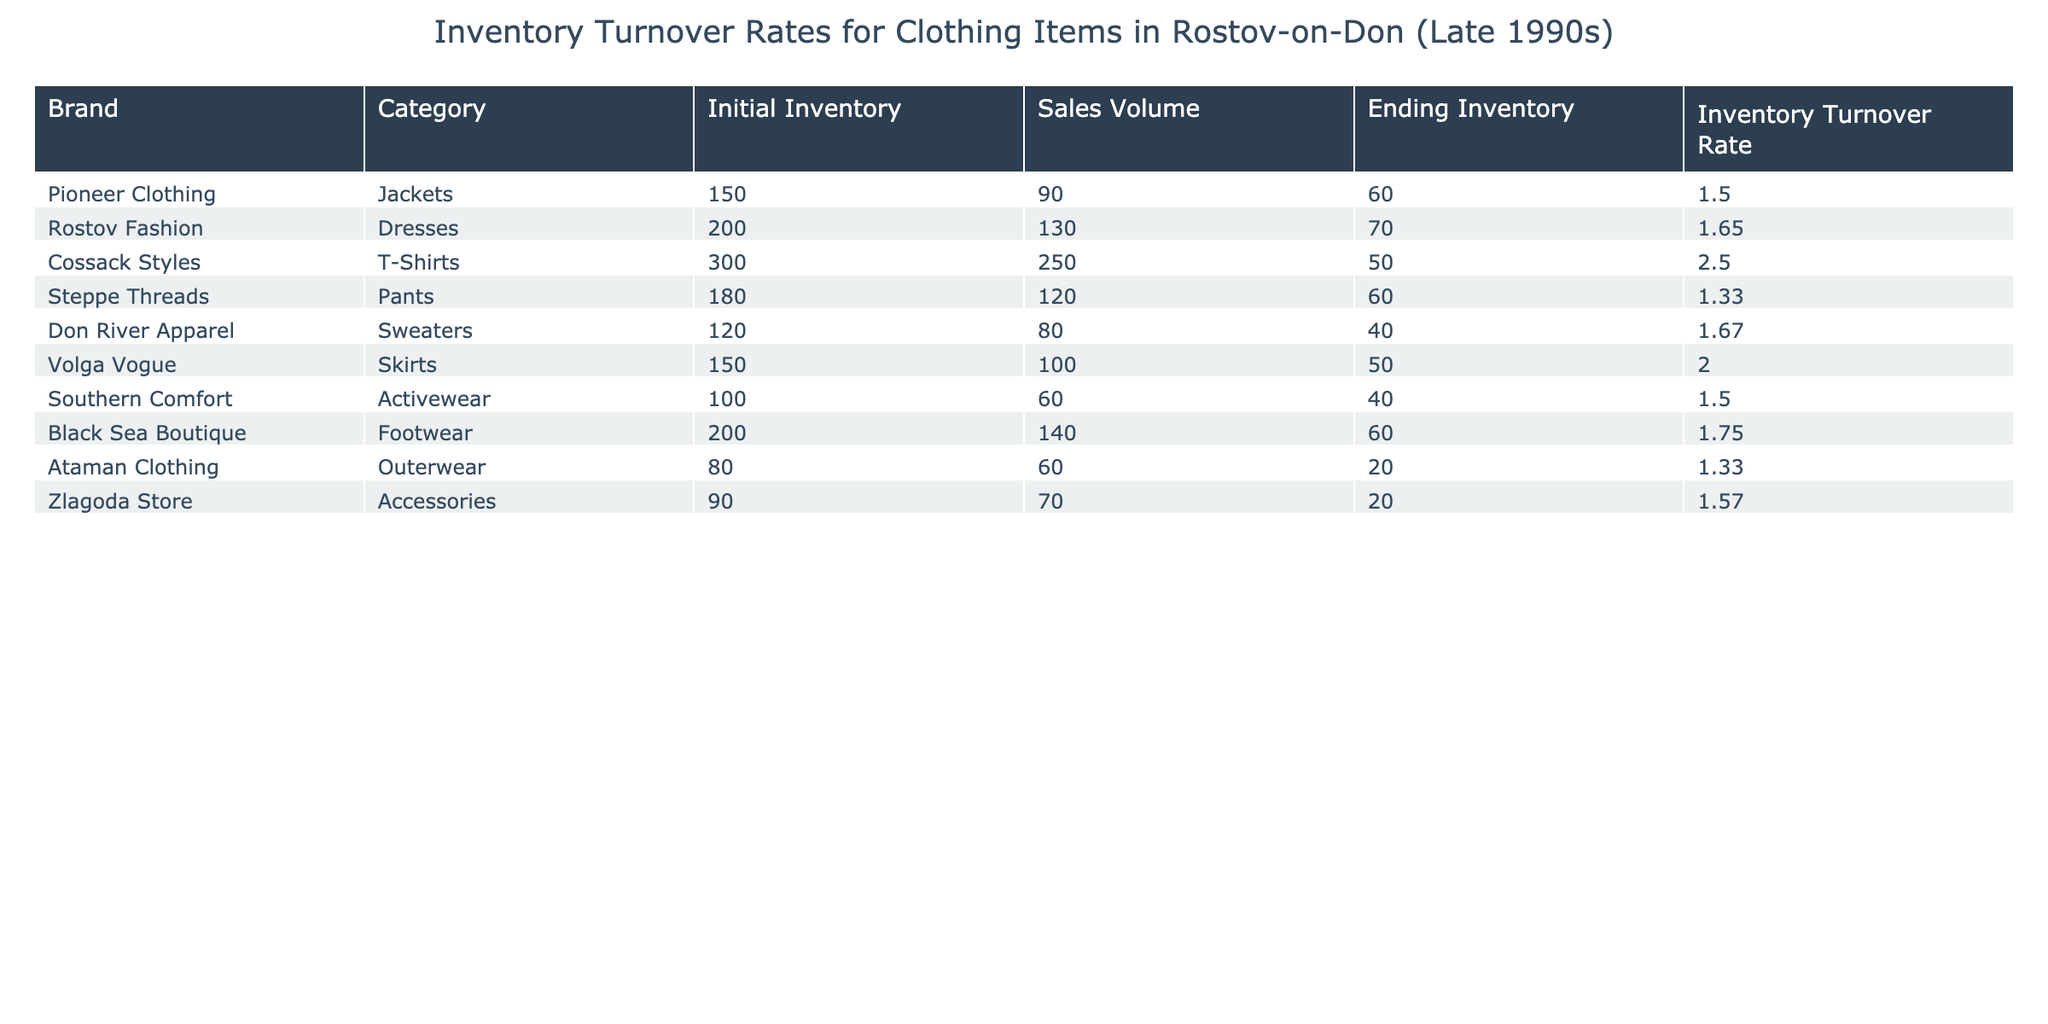What is the inventory turnover rate for Cossack Styles T-Shirts? The table indicates that the inventory turnover rate specifically for Cossack Styles T-Shirts is listed under the corresponding row. It shows a value of 2.5.
Answer: 2.5 Which clothing item had the highest inventory turnover rate? By examining the inventory turnover rates in the table, I find that the highest value is under Cossack Styles T-Shirts, which is 2.5.
Answer: Cossack Styles T-Shirts What is the total sales volume for all clothing items listed? To find the total sales volume, sum the sales volumes of each item: 90 + 130 + 250 + 120 + 80 + 100 + 60 + 140 + 60 + 70 = 1,100. The total sales volume is 1,100.
Answer: 1,100 Did any items have an ending inventory of 20 or less? Looking through the table, the only item that has an ending inventory of 20 or less is Ataman Clothing Outerwear, with an ending inventory of 20.
Answer: Yes What is the average inventory turnover rate for the clothing items listed? To calculate the average inventory turnover rate, sum all the turnover rates (1.5 + 1.65 + 2.5 + 1.33 + 1.67 + 2.0 + 1.5 + 1.75 + 1.33 + 1.57) = 15.4 and divide by 10 (the number of items), which gives 15.4 / 10 = 1.54.
Answer: 1.54 Which category sold the least volume compared to its initial inventory? By comparing the sales volume to the initial inventory for each item, I find that Ataman Clothing Outerwear sold 60 out of an initial inventory of 80, making the least sale ratio. It sold only 75% of its inventory.
Answer: Ataman Clothing Outerwear How many different brands are listed in the table? The table shows a list of ten clothing items with different brands. Each item has a unique brand name, resulting in a total of 10 brands.
Answer: 10 Is the inventory turnover rate for Southern Comfort Activewear above 1.5? The given inventory turnover rate for Southern Comfort Activewear is 1.5, which means it is not above 1.5.
Answer: No 